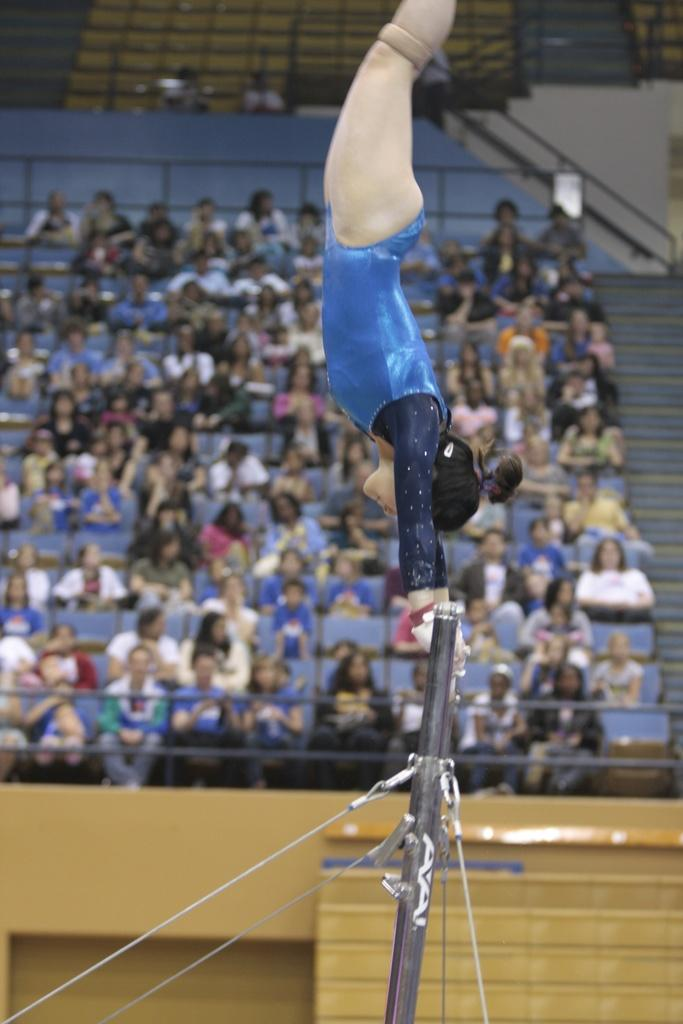What is the woman in the image doing? The woman is performing gymnastics in the image. Can you describe the setting of the image? There are people sitting in stands in the background of the image. What type of stone can be seen in the caption of the image? There is no stone or caption present in the image. How many heads of lettuce are visible in the image? There are no heads of lettuce present in the image. 